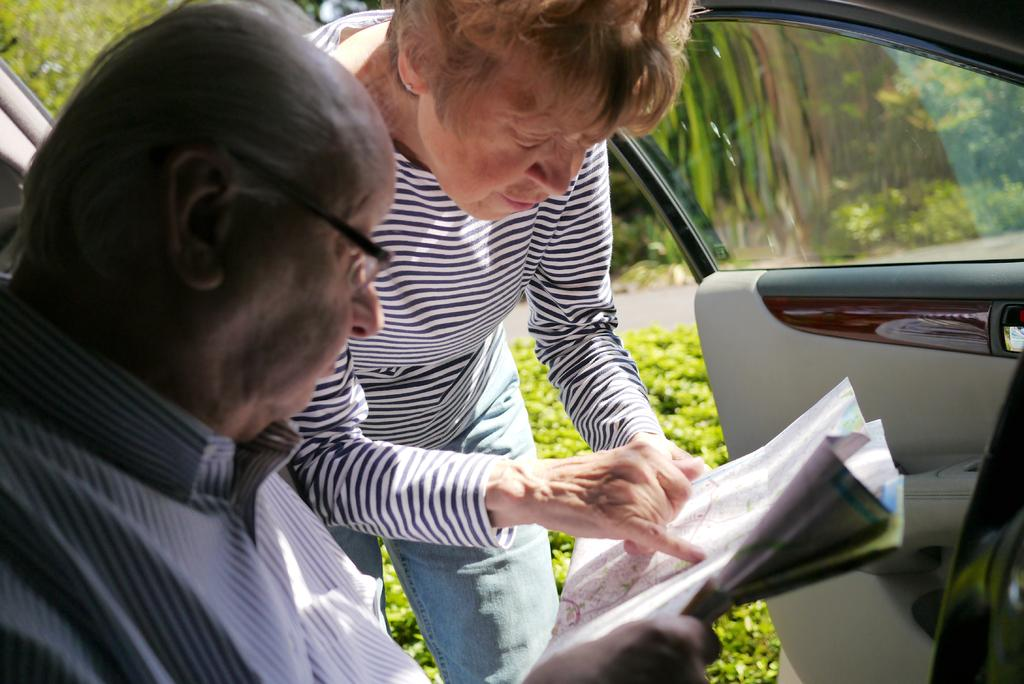What is the man in the image doing? The man is sitting in a car in the image. What is the woman in the image doing? The woman is standing in the image. What are the man and woman holding in the image? The man and woman are holding a paper in the image. What type of belief is the man expressing through the window in the image? There is no window or expression of belief present in the image. 